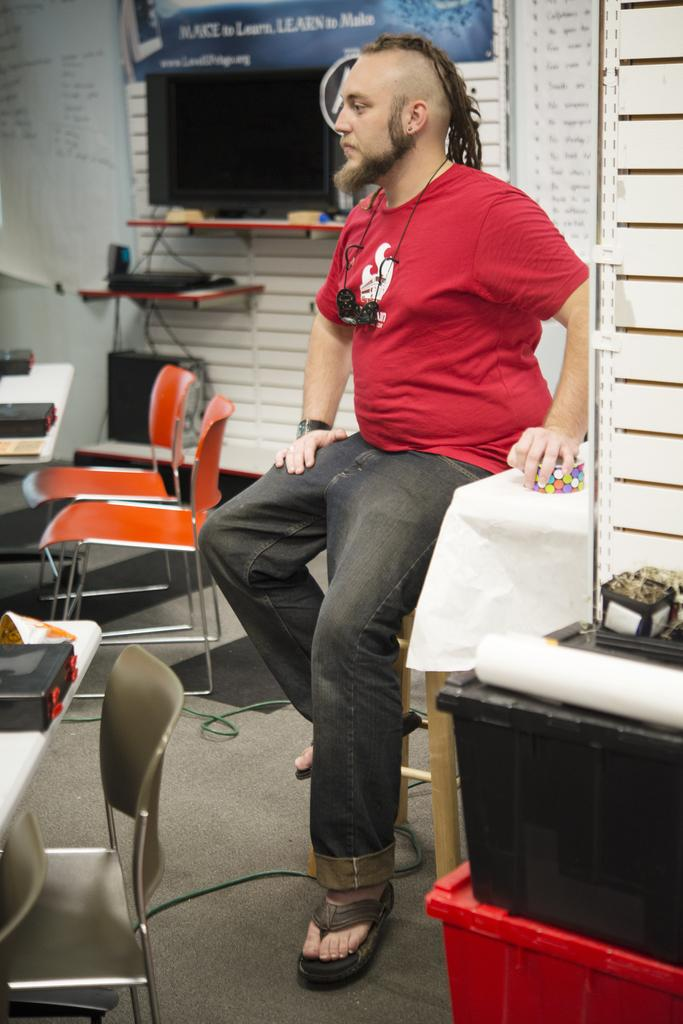What is the main subject in the center of the image? There is a person sitting on a stool in the center of the image. What type of furniture is present in the image? There are tables and chairs in the image. What electronic device is visible in the image? There is a monitor in the image. What type of structure is present in the image? There is a wall in the image. What is the board used for in the image? The board's purpose is not specified, but it is present in the image. Can you describe any other objects visible in the image? There are other objects visible in the image, but their specific details are not mentioned in the provided facts. What type of sand can be seen on the seat of the stool in the image? There is no sand present on the seat of the stool in the image. 